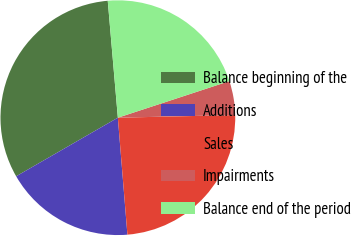Convert chart to OTSL. <chart><loc_0><loc_0><loc_500><loc_500><pie_chart><fcel>Balance beginning of the<fcel>Additions<fcel>Sales<fcel>Impairments<fcel>Balance end of the period<nl><fcel>31.95%<fcel>17.98%<fcel>24.06%<fcel>4.69%<fcel>21.33%<nl></chart> 